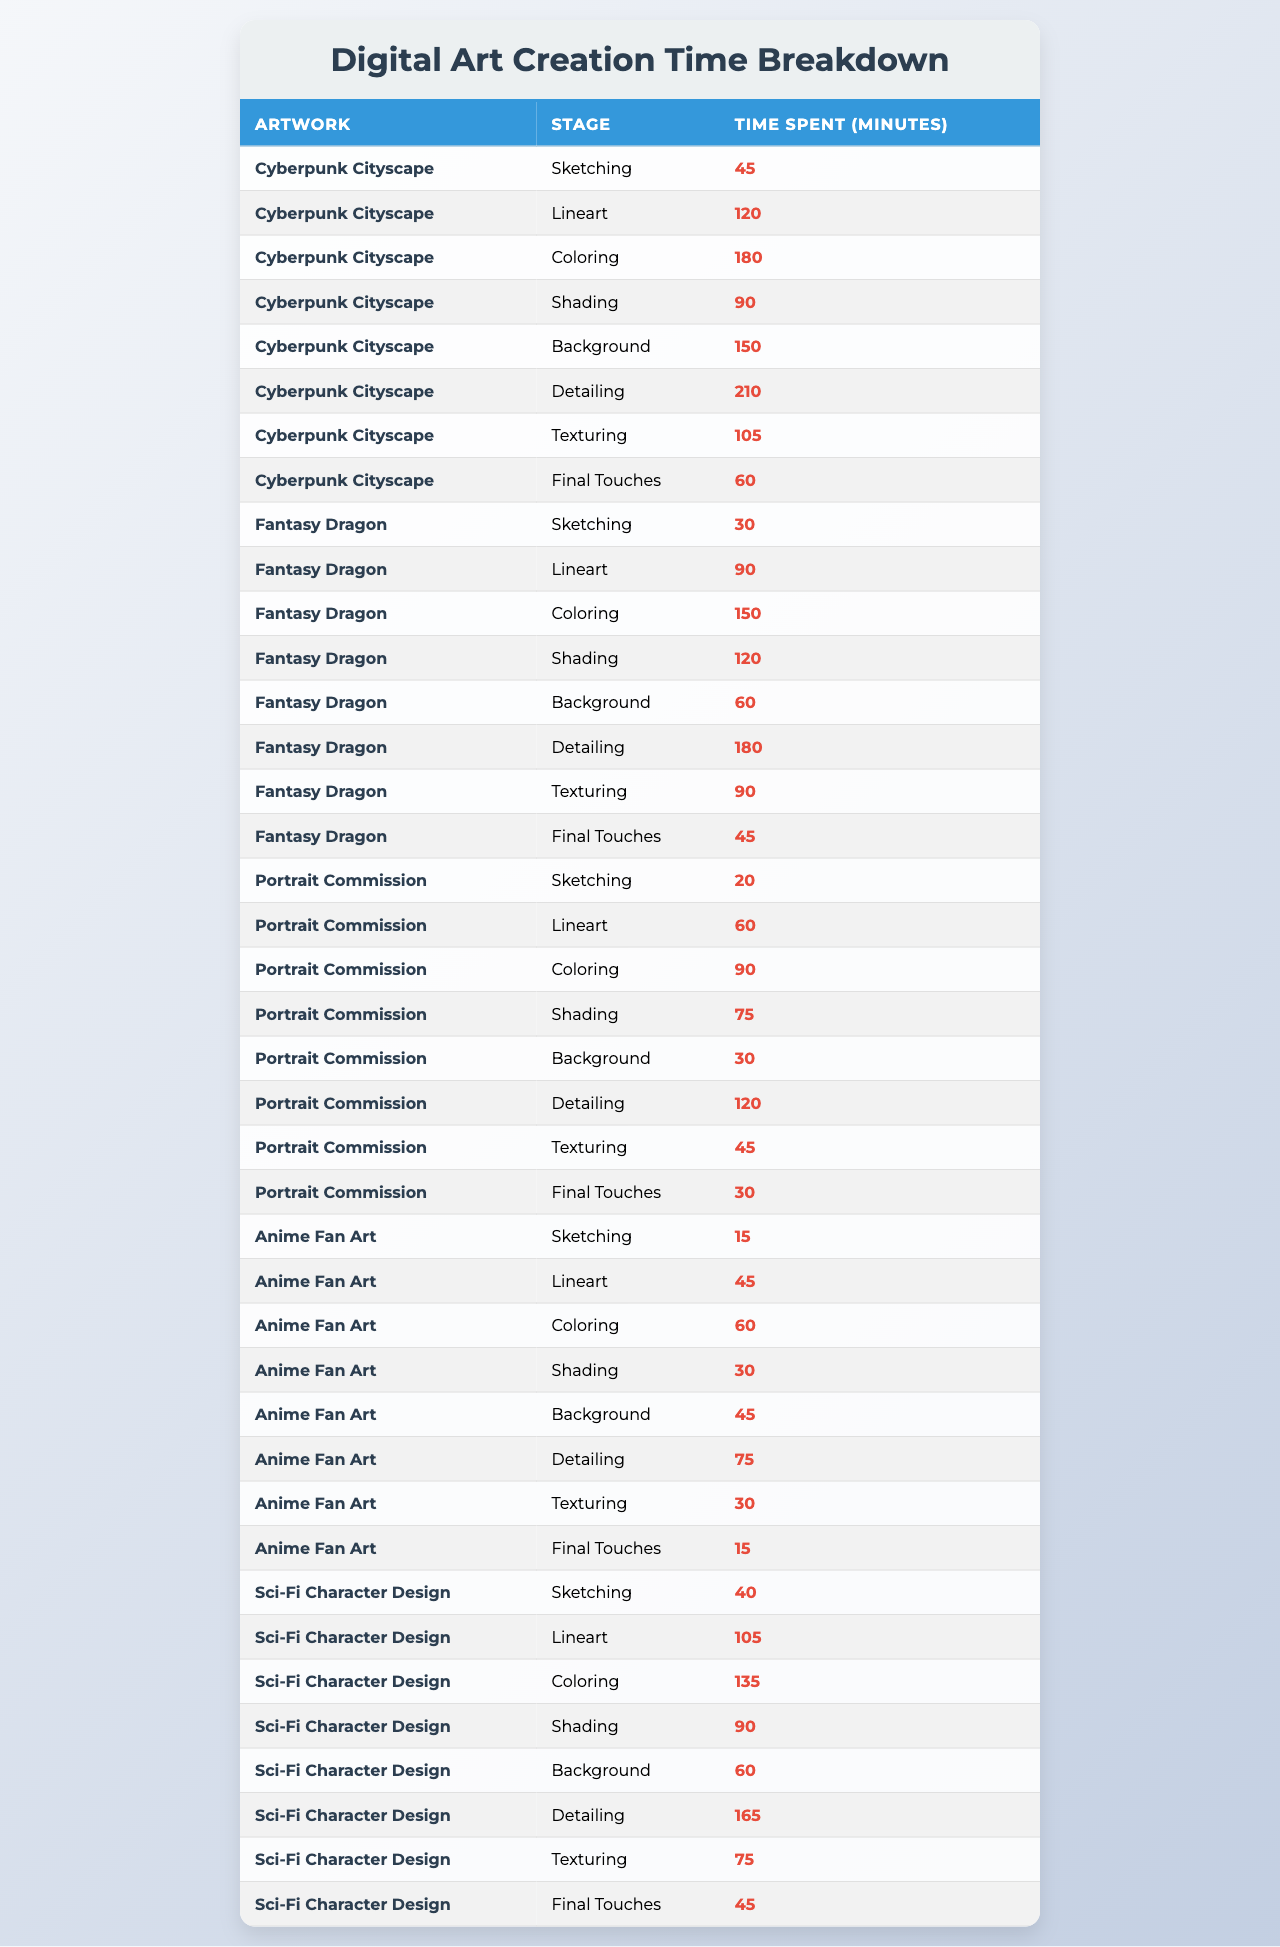What is the total time spent on the "Cyberpunk Cityscape"? To find the total time for the "Cyberpunk Cityscape," I will sum the time spent across all stages: 45 + 120 + 180 + 90 + 150 + 210 + 105 + 60 = 1050 minutes.
Answer: 1050 minutes Which stage took the longest time in the "Fantasy Dragon"? I will look at the time spent for each stage in the "Fantasy Dragon" artwork: 30 (Sketching), 90 (Lineart), 150 (Coloring), 120 (Shading), 60 (Background), 180 (Detailing), 90 (Texturing), and 45 (Final Touches). The longest time is 180 minutes (Detailing).
Answer: 180 minutes How much more time was spent on "Detailing" compared to "Final Touches" for the "Sci-Fi Character Design"? The time spent on "Detailing" for "Sci-Fi Character Design" is 165 minutes and on "Final Touches" is 45 minutes. So, 165 - 45 = 120 minutes more for "Detailing".
Answer: 120 minutes What is the average time spent on sketching across all artworks? For sketching, the times are 45, 30, 20, 15, and 40 minutes. Summing these gives 45 + 30 + 20 + 15 + 40 = 150 minutes. There are 5 artworks, so the average is 150/5 = 30 minutes.
Answer: 30 minutes Is there a stage where time spent was less than 20 minutes? I will check the time spent on each stage in the table. The minimum time recorded is 15 minutes in "Anime Fan Art" for Sketching. Thus, yes, there is a stage under 20 minutes.
Answer: Yes Which artwork had the highest total time spent on all stages combined? First, I will calculate total time for each artwork: "Cyberpunk Cityscape" = 1050, "Fantasy Dragon" = 630, "Portrait Commission" = 450, "Anime Fan Art" = 330, "Sci-Fi Character Design" = 510. The highest is "Cyberpunk Cityscape" with 1050 minutes.
Answer: Cyberpunk Cityscape How much time was spent on "Coloring" for all artworks combined? I will sum the time spent on "Coloring" for each artwork: 180 (Cyberpunk Cityscape) + 150 (Fantasy Dragon) + 90 (Portrait Commission) + 60 (Anime Fan Art) + 135 (Sci-Fi Character Design) = 615 minutes for "Coloring" in total.
Answer: 615 minutes What is the difference in total time spent between the longest and shortest artworks? The longest is "Cyberpunk Cityscape" at 1050 minutes, and the shortest is "Anime Fan Art" at 330 minutes. The difference is 1050 - 330 = 720 minutes.
Answer: 720 minutes 